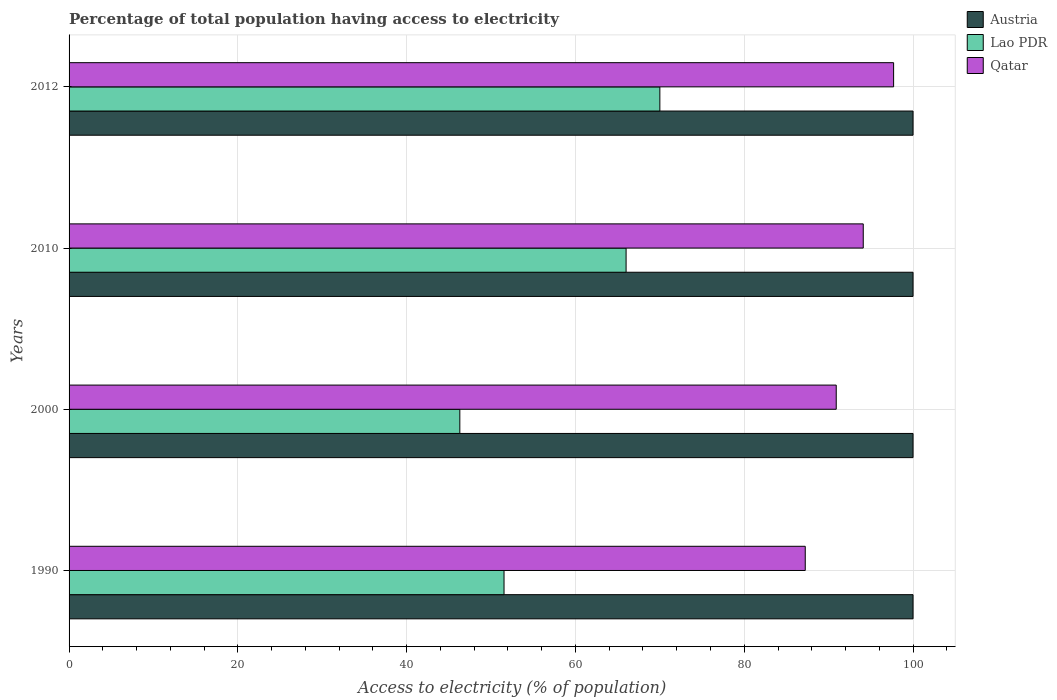How many different coloured bars are there?
Your response must be concise. 3. How many groups of bars are there?
Provide a short and direct response. 4. Are the number of bars on each tick of the Y-axis equal?
Your response must be concise. Yes. How many bars are there on the 1st tick from the bottom?
Your answer should be very brief. 3. What is the label of the 1st group of bars from the top?
Offer a terse response. 2012. In how many cases, is the number of bars for a given year not equal to the number of legend labels?
Keep it short and to the point. 0. What is the percentage of population that have access to electricity in Qatar in 2012?
Offer a very short reply. 97.7. Across all years, what is the minimum percentage of population that have access to electricity in Qatar?
Your answer should be very brief. 87.23. What is the total percentage of population that have access to electricity in Qatar in the graph?
Make the answer very short. 369.92. What is the difference between the percentage of population that have access to electricity in Lao PDR in 1990 and that in 2000?
Your answer should be compact. 5.24. What is the difference between the percentage of population that have access to electricity in Austria in 2000 and the percentage of population that have access to electricity in Qatar in 2012?
Ensure brevity in your answer.  2.3. What is the average percentage of population that have access to electricity in Lao PDR per year?
Ensure brevity in your answer.  58.46. In the year 1990, what is the difference between the percentage of population that have access to electricity in Lao PDR and percentage of population that have access to electricity in Austria?
Make the answer very short. -48.46. What is the ratio of the percentage of population that have access to electricity in Lao PDR in 2000 to that in 2012?
Your answer should be compact. 0.66. Is the percentage of population that have access to electricity in Qatar in 2000 less than that in 2012?
Give a very brief answer. Yes. Is the difference between the percentage of population that have access to electricity in Lao PDR in 1990 and 2000 greater than the difference between the percentage of population that have access to electricity in Austria in 1990 and 2000?
Make the answer very short. Yes. What is the difference between the highest and the lowest percentage of population that have access to electricity in Qatar?
Your answer should be compact. 10.47. Is the sum of the percentage of population that have access to electricity in Qatar in 2000 and 2010 greater than the maximum percentage of population that have access to electricity in Austria across all years?
Keep it short and to the point. Yes. What does the 2nd bar from the top in 2012 represents?
Provide a short and direct response. Lao PDR. What does the 1st bar from the bottom in 1990 represents?
Give a very brief answer. Austria. Is it the case that in every year, the sum of the percentage of population that have access to electricity in Lao PDR and percentage of population that have access to electricity in Austria is greater than the percentage of population that have access to electricity in Qatar?
Keep it short and to the point. Yes. How many bars are there?
Keep it short and to the point. 12. How many years are there in the graph?
Provide a short and direct response. 4. What is the difference between two consecutive major ticks on the X-axis?
Offer a very short reply. 20. Are the values on the major ticks of X-axis written in scientific E-notation?
Give a very brief answer. No. Where does the legend appear in the graph?
Your answer should be compact. Top right. How are the legend labels stacked?
Ensure brevity in your answer.  Vertical. What is the title of the graph?
Give a very brief answer. Percentage of total population having access to electricity. What is the label or title of the X-axis?
Your answer should be compact. Access to electricity (% of population). What is the label or title of the Y-axis?
Offer a terse response. Years. What is the Access to electricity (% of population) in Lao PDR in 1990?
Offer a very short reply. 51.54. What is the Access to electricity (% of population) in Qatar in 1990?
Your answer should be very brief. 87.23. What is the Access to electricity (% of population) of Austria in 2000?
Make the answer very short. 100. What is the Access to electricity (% of population) of Lao PDR in 2000?
Give a very brief answer. 46.3. What is the Access to electricity (% of population) of Qatar in 2000?
Offer a very short reply. 90.9. What is the Access to electricity (% of population) of Austria in 2010?
Keep it short and to the point. 100. What is the Access to electricity (% of population) in Lao PDR in 2010?
Ensure brevity in your answer.  66. What is the Access to electricity (% of population) of Qatar in 2010?
Ensure brevity in your answer.  94.1. What is the Access to electricity (% of population) of Austria in 2012?
Offer a very short reply. 100. What is the Access to electricity (% of population) in Qatar in 2012?
Make the answer very short. 97.7. Across all years, what is the maximum Access to electricity (% of population) in Qatar?
Your answer should be very brief. 97.7. Across all years, what is the minimum Access to electricity (% of population) in Austria?
Offer a very short reply. 100. Across all years, what is the minimum Access to electricity (% of population) of Lao PDR?
Provide a short and direct response. 46.3. Across all years, what is the minimum Access to electricity (% of population) in Qatar?
Give a very brief answer. 87.23. What is the total Access to electricity (% of population) of Lao PDR in the graph?
Ensure brevity in your answer.  233.84. What is the total Access to electricity (% of population) in Qatar in the graph?
Provide a succinct answer. 369.92. What is the difference between the Access to electricity (% of population) of Lao PDR in 1990 and that in 2000?
Keep it short and to the point. 5.24. What is the difference between the Access to electricity (% of population) of Qatar in 1990 and that in 2000?
Provide a short and direct response. -3.67. What is the difference between the Access to electricity (% of population) in Austria in 1990 and that in 2010?
Keep it short and to the point. 0. What is the difference between the Access to electricity (% of population) of Lao PDR in 1990 and that in 2010?
Make the answer very short. -14.46. What is the difference between the Access to electricity (% of population) in Qatar in 1990 and that in 2010?
Your answer should be compact. -6.87. What is the difference between the Access to electricity (% of population) in Lao PDR in 1990 and that in 2012?
Offer a very short reply. -18.46. What is the difference between the Access to electricity (% of population) in Qatar in 1990 and that in 2012?
Give a very brief answer. -10.47. What is the difference between the Access to electricity (% of population) in Austria in 2000 and that in 2010?
Your response must be concise. 0. What is the difference between the Access to electricity (% of population) of Lao PDR in 2000 and that in 2010?
Give a very brief answer. -19.7. What is the difference between the Access to electricity (% of population) of Qatar in 2000 and that in 2010?
Make the answer very short. -3.2. What is the difference between the Access to electricity (% of population) of Lao PDR in 2000 and that in 2012?
Your answer should be compact. -23.7. What is the difference between the Access to electricity (% of population) of Qatar in 2000 and that in 2012?
Give a very brief answer. -6.8. What is the difference between the Access to electricity (% of population) of Austria in 2010 and that in 2012?
Your response must be concise. 0. What is the difference between the Access to electricity (% of population) of Lao PDR in 2010 and that in 2012?
Your answer should be compact. -4. What is the difference between the Access to electricity (% of population) in Qatar in 2010 and that in 2012?
Your answer should be very brief. -3.6. What is the difference between the Access to electricity (% of population) in Austria in 1990 and the Access to electricity (% of population) in Lao PDR in 2000?
Ensure brevity in your answer.  53.7. What is the difference between the Access to electricity (% of population) in Austria in 1990 and the Access to electricity (% of population) in Qatar in 2000?
Your answer should be very brief. 9.1. What is the difference between the Access to electricity (% of population) in Lao PDR in 1990 and the Access to electricity (% of population) in Qatar in 2000?
Offer a terse response. -39.36. What is the difference between the Access to electricity (% of population) of Lao PDR in 1990 and the Access to electricity (% of population) of Qatar in 2010?
Offer a terse response. -42.56. What is the difference between the Access to electricity (% of population) of Austria in 1990 and the Access to electricity (% of population) of Qatar in 2012?
Provide a short and direct response. 2.3. What is the difference between the Access to electricity (% of population) in Lao PDR in 1990 and the Access to electricity (% of population) in Qatar in 2012?
Ensure brevity in your answer.  -46.16. What is the difference between the Access to electricity (% of population) in Austria in 2000 and the Access to electricity (% of population) in Lao PDR in 2010?
Provide a short and direct response. 34. What is the difference between the Access to electricity (% of population) in Austria in 2000 and the Access to electricity (% of population) in Qatar in 2010?
Your answer should be compact. 5.9. What is the difference between the Access to electricity (% of population) in Lao PDR in 2000 and the Access to electricity (% of population) in Qatar in 2010?
Make the answer very short. -47.8. What is the difference between the Access to electricity (% of population) of Austria in 2000 and the Access to electricity (% of population) of Lao PDR in 2012?
Your answer should be compact. 30. What is the difference between the Access to electricity (% of population) of Austria in 2000 and the Access to electricity (% of population) of Qatar in 2012?
Make the answer very short. 2.3. What is the difference between the Access to electricity (% of population) in Lao PDR in 2000 and the Access to electricity (% of population) in Qatar in 2012?
Provide a succinct answer. -51.4. What is the difference between the Access to electricity (% of population) in Austria in 2010 and the Access to electricity (% of population) in Lao PDR in 2012?
Give a very brief answer. 30. What is the difference between the Access to electricity (% of population) in Austria in 2010 and the Access to electricity (% of population) in Qatar in 2012?
Ensure brevity in your answer.  2.3. What is the difference between the Access to electricity (% of population) of Lao PDR in 2010 and the Access to electricity (% of population) of Qatar in 2012?
Ensure brevity in your answer.  -31.7. What is the average Access to electricity (% of population) of Austria per year?
Make the answer very short. 100. What is the average Access to electricity (% of population) in Lao PDR per year?
Provide a short and direct response. 58.46. What is the average Access to electricity (% of population) in Qatar per year?
Your response must be concise. 92.48. In the year 1990, what is the difference between the Access to electricity (% of population) of Austria and Access to electricity (% of population) of Lao PDR?
Your answer should be very brief. 48.46. In the year 1990, what is the difference between the Access to electricity (% of population) of Austria and Access to electricity (% of population) of Qatar?
Offer a very short reply. 12.77. In the year 1990, what is the difference between the Access to electricity (% of population) of Lao PDR and Access to electricity (% of population) of Qatar?
Your response must be concise. -35.69. In the year 2000, what is the difference between the Access to electricity (% of population) in Austria and Access to electricity (% of population) in Lao PDR?
Give a very brief answer. 53.7. In the year 2000, what is the difference between the Access to electricity (% of population) in Austria and Access to electricity (% of population) in Qatar?
Offer a very short reply. 9.1. In the year 2000, what is the difference between the Access to electricity (% of population) in Lao PDR and Access to electricity (% of population) in Qatar?
Ensure brevity in your answer.  -44.6. In the year 2010, what is the difference between the Access to electricity (% of population) in Lao PDR and Access to electricity (% of population) in Qatar?
Your response must be concise. -28.1. In the year 2012, what is the difference between the Access to electricity (% of population) in Austria and Access to electricity (% of population) in Qatar?
Your response must be concise. 2.3. In the year 2012, what is the difference between the Access to electricity (% of population) in Lao PDR and Access to electricity (% of population) in Qatar?
Offer a terse response. -27.7. What is the ratio of the Access to electricity (% of population) in Austria in 1990 to that in 2000?
Provide a succinct answer. 1. What is the ratio of the Access to electricity (% of population) in Lao PDR in 1990 to that in 2000?
Make the answer very short. 1.11. What is the ratio of the Access to electricity (% of population) of Qatar in 1990 to that in 2000?
Your response must be concise. 0.96. What is the ratio of the Access to electricity (% of population) in Austria in 1990 to that in 2010?
Give a very brief answer. 1. What is the ratio of the Access to electricity (% of population) in Lao PDR in 1990 to that in 2010?
Offer a very short reply. 0.78. What is the ratio of the Access to electricity (% of population) of Qatar in 1990 to that in 2010?
Your answer should be compact. 0.93. What is the ratio of the Access to electricity (% of population) in Austria in 1990 to that in 2012?
Provide a succinct answer. 1. What is the ratio of the Access to electricity (% of population) in Lao PDR in 1990 to that in 2012?
Ensure brevity in your answer.  0.74. What is the ratio of the Access to electricity (% of population) in Qatar in 1990 to that in 2012?
Provide a succinct answer. 0.89. What is the ratio of the Access to electricity (% of population) of Austria in 2000 to that in 2010?
Your response must be concise. 1. What is the ratio of the Access to electricity (% of population) of Lao PDR in 2000 to that in 2010?
Give a very brief answer. 0.7. What is the ratio of the Access to electricity (% of population) in Qatar in 2000 to that in 2010?
Your answer should be compact. 0.97. What is the ratio of the Access to electricity (% of population) in Austria in 2000 to that in 2012?
Your answer should be compact. 1. What is the ratio of the Access to electricity (% of population) of Lao PDR in 2000 to that in 2012?
Offer a very short reply. 0.66. What is the ratio of the Access to electricity (% of population) of Qatar in 2000 to that in 2012?
Ensure brevity in your answer.  0.93. What is the ratio of the Access to electricity (% of population) in Lao PDR in 2010 to that in 2012?
Ensure brevity in your answer.  0.94. What is the ratio of the Access to electricity (% of population) of Qatar in 2010 to that in 2012?
Keep it short and to the point. 0.96. What is the difference between the highest and the second highest Access to electricity (% of population) of Austria?
Make the answer very short. 0. What is the difference between the highest and the second highest Access to electricity (% of population) in Lao PDR?
Your response must be concise. 4. What is the difference between the highest and the second highest Access to electricity (% of population) in Qatar?
Provide a succinct answer. 3.6. What is the difference between the highest and the lowest Access to electricity (% of population) of Lao PDR?
Offer a terse response. 23.7. What is the difference between the highest and the lowest Access to electricity (% of population) of Qatar?
Offer a very short reply. 10.47. 